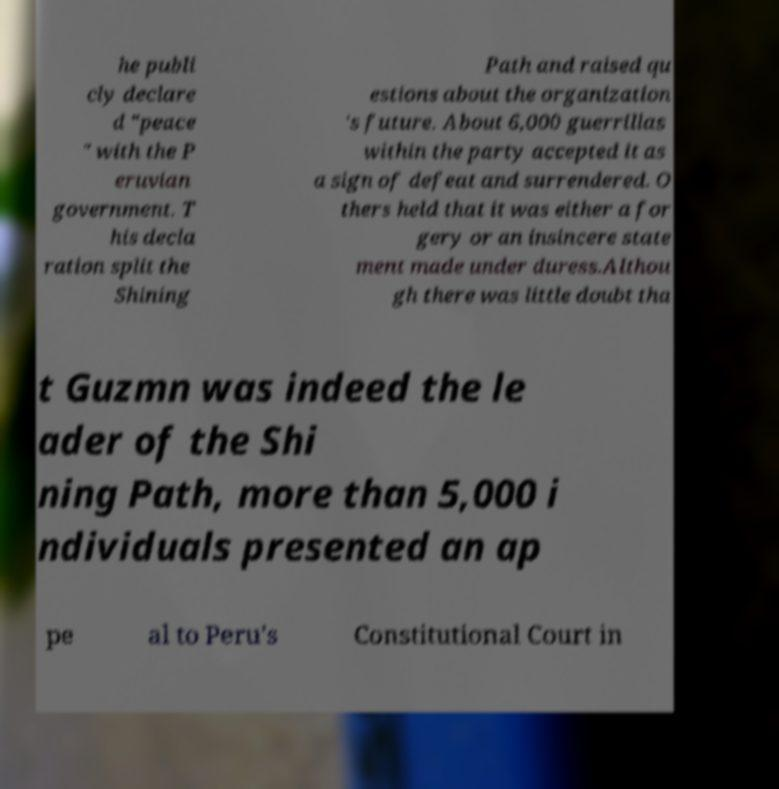Please identify and transcribe the text found in this image. he publi cly declare d "peace " with the P eruvian government. T his decla ration split the Shining Path and raised qu estions about the organization 's future. About 6,000 guerrillas within the party accepted it as a sign of defeat and surrendered. O thers held that it was either a for gery or an insincere state ment made under duress.Althou gh there was little doubt tha t Guzmn was indeed the le ader of the Shi ning Path, more than 5,000 i ndividuals presented an ap pe al to Peru's Constitutional Court in 